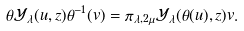Convert formula to latex. <formula><loc_0><loc_0><loc_500><loc_500>\theta \mathcal { Y } _ { \lambda } ( u , z ) \theta ^ { - 1 } ( v ) = \pi _ { \lambda , 2 \mu } \mathcal { Y } _ { \lambda } ( \theta ( u ) , z ) v .</formula> 